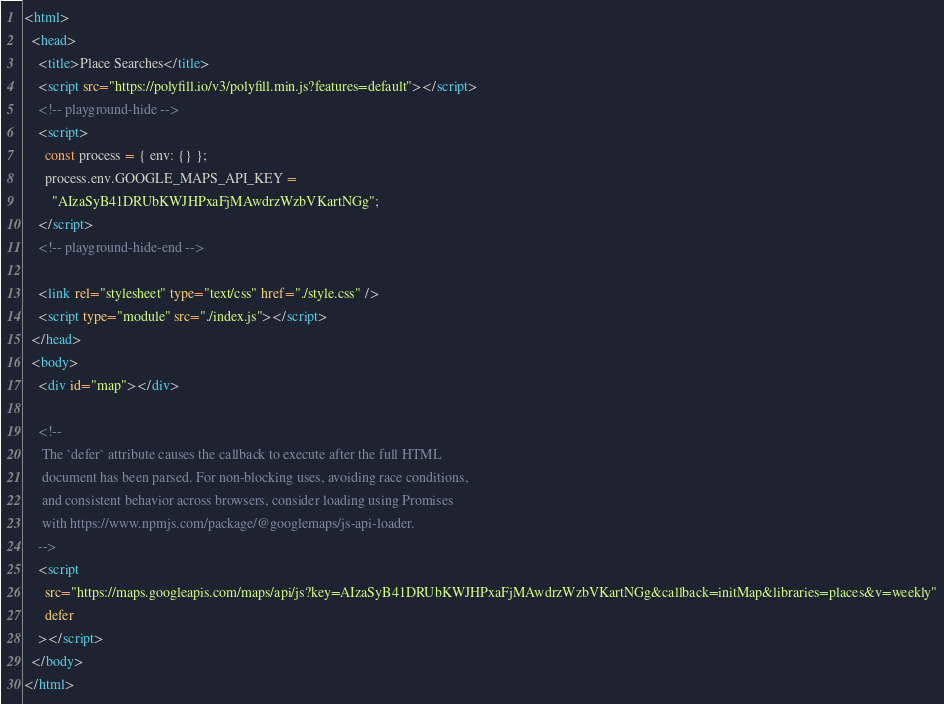<code> <loc_0><loc_0><loc_500><loc_500><_HTML_><html>
  <head>
    <title>Place Searches</title>
    <script src="https://polyfill.io/v3/polyfill.min.js?features=default"></script>
    <!-- playground-hide -->
    <script>
      const process = { env: {} };
      process.env.GOOGLE_MAPS_API_KEY =
        "AIzaSyB41DRUbKWJHPxaFjMAwdrzWzbVKartNGg";
    </script>
    <!-- playground-hide-end -->

    <link rel="stylesheet" type="text/css" href="./style.css" />
    <script type="module" src="./index.js"></script>
  </head>
  <body>
    <div id="map"></div>

    <!-- 
     The `defer` attribute causes the callback to execute after the full HTML
     document has been parsed. For non-blocking uses, avoiding race conditions,
     and consistent behavior across browsers, consider loading using Promises
     with https://www.npmjs.com/package/@googlemaps/js-api-loader.
    -->
    <script
      src="https://maps.googleapis.com/maps/api/js?key=AIzaSyB41DRUbKWJHPxaFjMAwdrzWzbVKartNGg&callback=initMap&libraries=places&v=weekly"
      defer
    ></script>
  </body>
</html>
</code> 